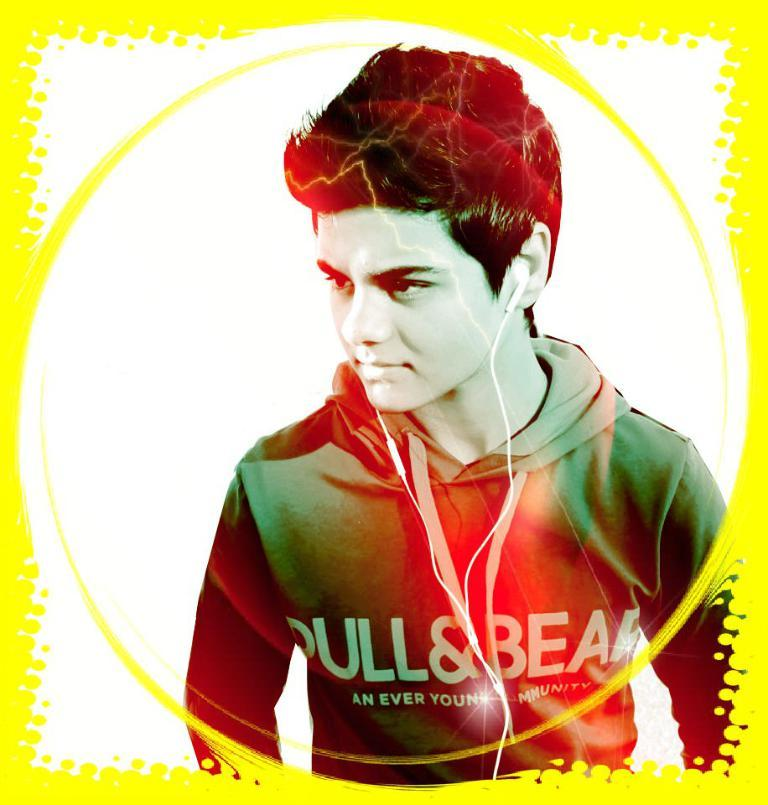<image>
Present a compact description of the photo's key features. Boy wearing a hoodie that says "An Ever" on it posing for something. 